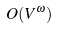<formula> <loc_0><loc_0><loc_500><loc_500>O ( V ^ { \omega } )</formula> 